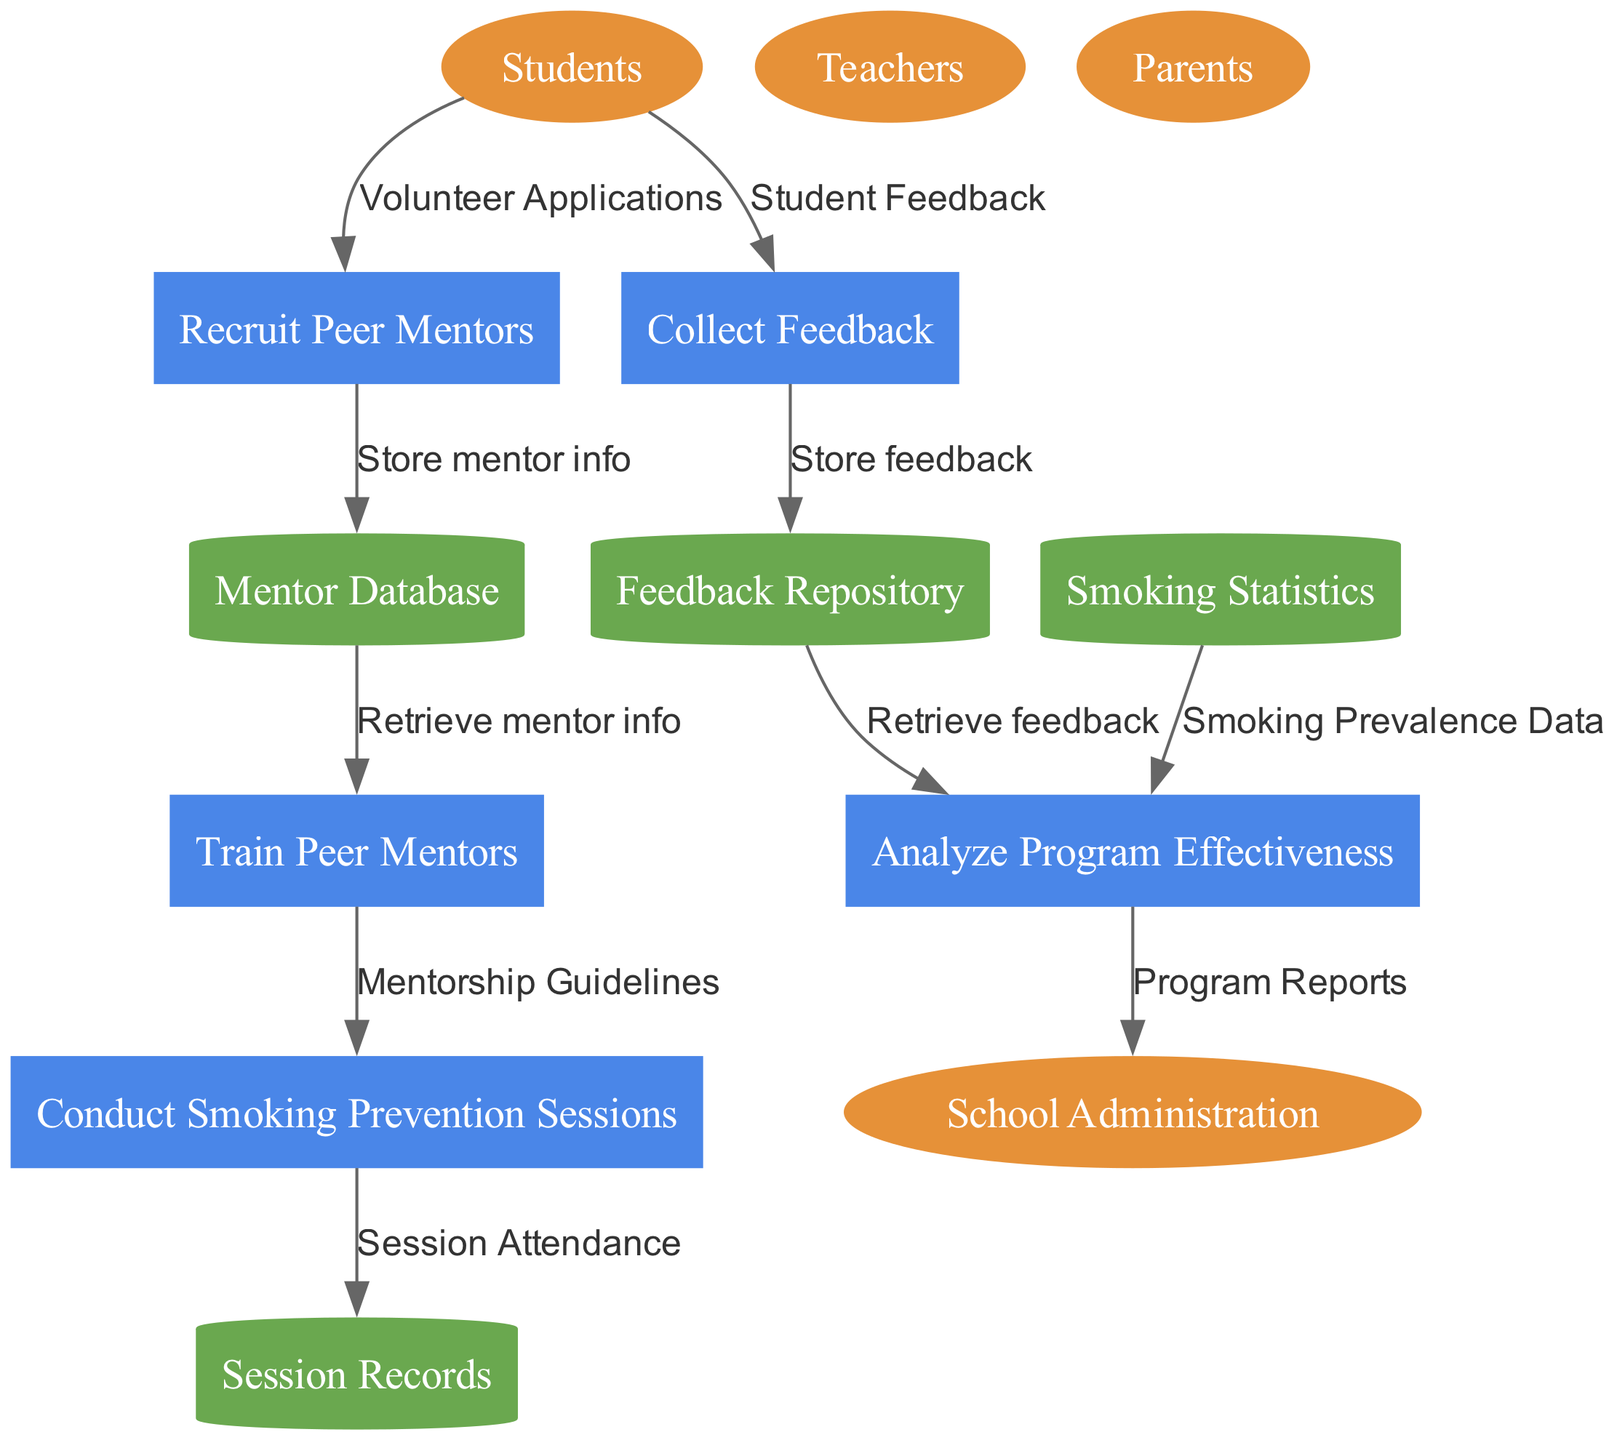What are the external entities involved in this program? The external entities are listed clearly at the start of the diagram. They include Students, Teachers, School Administration, and Parents.
Answer: Students, Teachers, School Administration, Parents How many processes are there in the diagram? By counting the number of processes listed, we see that there are five distinct processes involved in the peer support program: Recruit Peer Mentors, Train Peer Mentors, Conduct Smoking Prevention Sessions, Collect Feedback, and Analyze Program Effectiveness.
Answer: Five Which process retrieves mentorship guidelines? Following the flow in the diagram, the process that retrieves mentorship guidelines is "Train Peer Mentors," as it uses these guidelines for the next step.
Answer: Train Peer Mentors What is stored in the Feedback Repository? The Feedback Repository is specifically used to store feedback collected from students, as indicated by the data flow directed toward it.
Answer: Student Feedback Which external entity provides volunteer applications? The external entity that provides the volunteer applications is "Students," who are responsible for applying to become peer mentors.
Answer: Students Which data flow is connected to the process of analyzing program effectiveness? The process of analyzing program effectiveness connects with two data flows: "Smoking Prevalence Data" and "Retrieve feedback" from the Feedback Repository, highlighting its reliance on both sources to determine efficacy.
Answer: Smoking Prevalence Data, Retrieve feedback Which data store holds session attendance information? The Session Records data store holds the session attendance information generated from the Conduct Smoking Prevention Sessions process, where attendance is recorded.
Answer: Session Records How do collected feedback and feedback repository relate? The flow of data indicates that the collected feedback from students is directed towards the Feedback Repository for storage, establishing a direct relationship between the two.
Answer: Store feedback What is the final output of the Analyze Program Effectiveness process? The output of the Analyze Program Effectiveness process is the Program Reports, which are sent to the School Administration to summarize the results and recommendations from the analysis.
Answer: Program Reports 